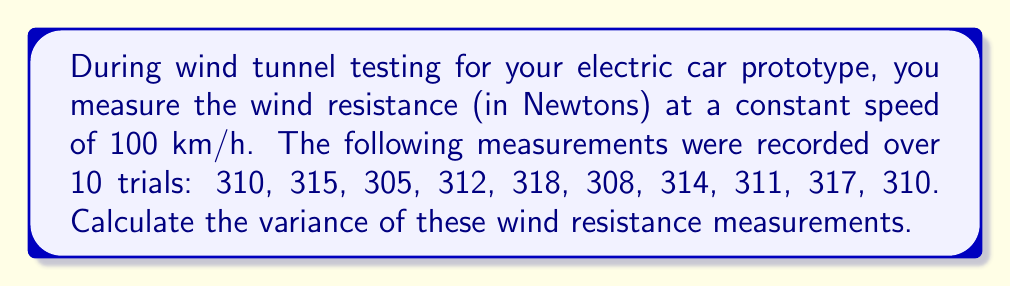Teach me how to tackle this problem. To calculate the variance of the wind resistance measurements, we'll follow these steps:

1. Calculate the mean ($\mu$) of the measurements:
   $$\mu = \frac{310 + 315 + 305 + 312 + 318 + 308 + 314 + 311 + 317 + 310}{10} = 313 \text{ N}$$

2. Calculate the squared differences from the mean:
   $$(310 - 313)^2 = (-3)^2 = 9$$
   $$(315 - 313)^2 = (2)^2 = 4$$
   $$(305 - 313)^2 = (-8)^2 = 64$$
   $$(312 - 313)^2 = (-1)^2 = 1$$
   $$(318 - 313)^2 = (5)^2 = 25$$
   $$(308 - 313)^2 = (-5)^2 = 25$$
   $$(314 - 313)^2 = (1)^2 = 1$$
   $$(311 - 313)^2 = (-2)^2 = 4$$
   $$(317 - 313)^2 = (4)^2 = 16$$
   $$(310 - 313)^2 = (-3)^2 = 9$$

3. Sum the squared differences:
   $$9 + 4 + 64 + 1 + 25 + 25 + 1 + 4 + 16 + 9 = 158$$

4. Divide by the number of measurements (n = 10) to get the variance:
   $$\text{Variance} = \frac{158}{10} = 15.8 \text{ N}^2$$

The formula for variance is:
$$\sigma^2 = \frac{\sum_{i=1}^n (x_i - \mu)^2}{n}$$

where $\sigma^2$ is the variance, $x_i$ are the individual measurements, $\mu$ is the mean, and $n$ is the number of measurements.
Answer: The variance of the wind resistance measurements is 15.8 N². 